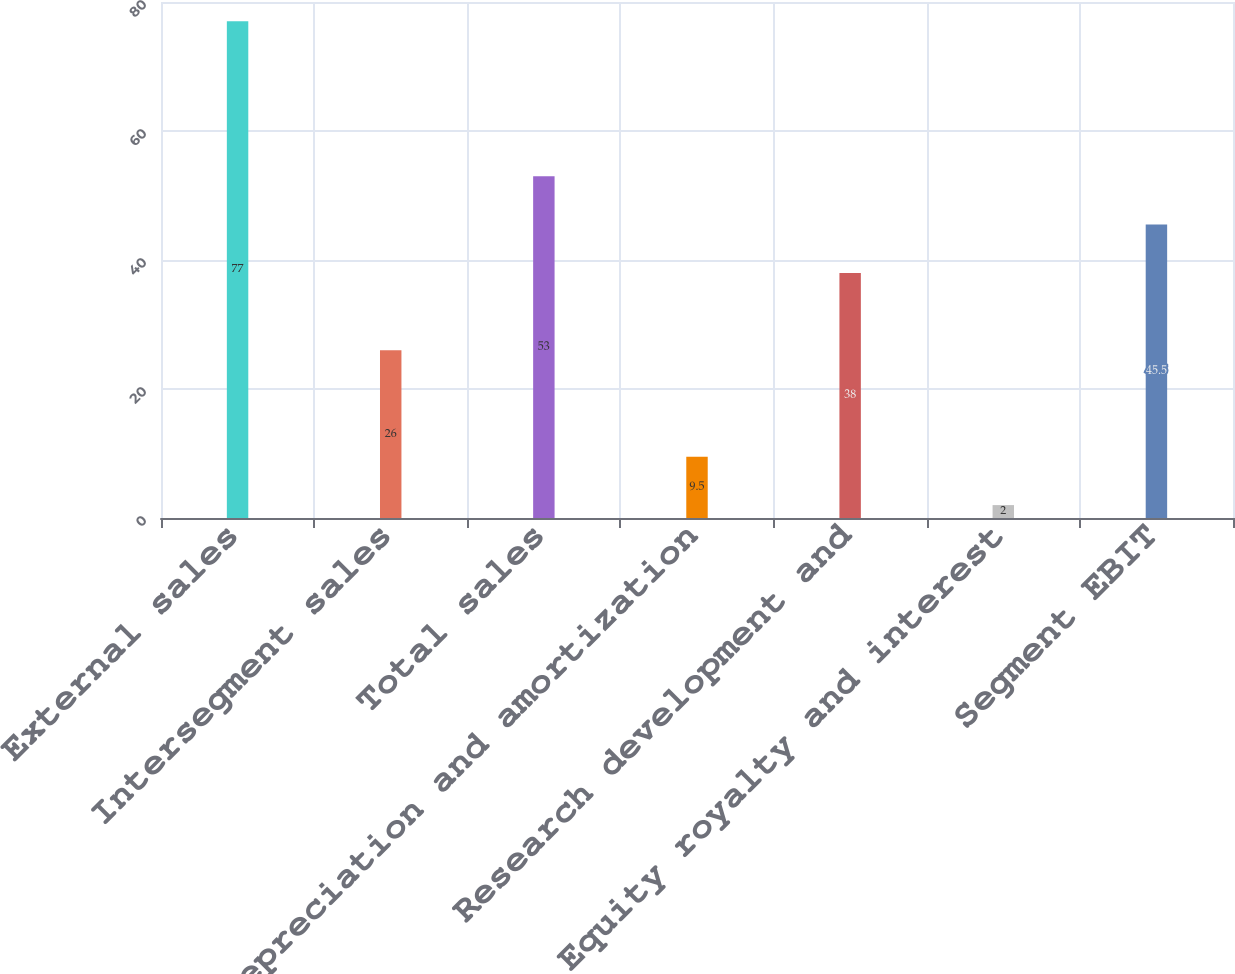Convert chart to OTSL. <chart><loc_0><loc_0><loc_500><loc_500><bar_chart><fcel>External sales<fcel>Intersegment sales<fcel>Total sales<fcel>Depreciation and amortization<fcel>Research development and<fcel>Equity royalty and interest<fcel>Segment EBIT<nl><fcel>77<fcel>26<fcel>53<fcel>9.5<fcel>38<fcel>2<fcel>45.5<nl></chart> 